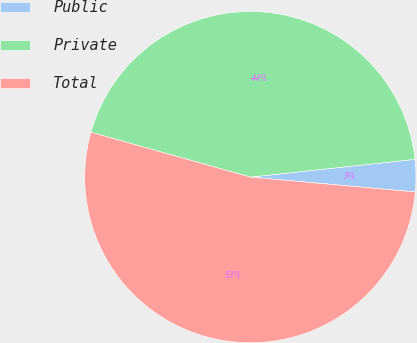Convert chart. <chart><loc_0><loc_0><loc_500><loc_500><pie_chart><fcel>Public<fcel>Private<fcel>Total<nl><fcel>3.14%<fcel>43.92%<fcel>52.94%<nl></chart> 